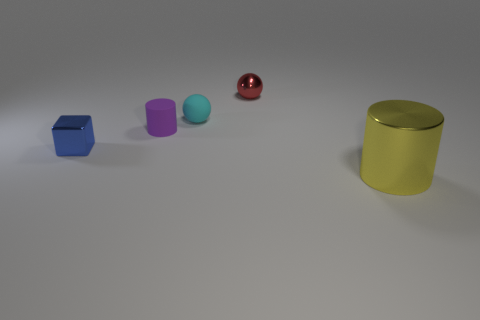Are the small cyan thing and the small block made of the same material?
Offer a terse response. No. Are there any matte cylinders in front of the cylinder that is on the left side of the large yellow metallic cylinder?
Offer a terse response. No. What number of small objects are left of the tiny cyan rubber sphere and behind the small cyan ball?
Provide a succinct answer. 0. There is a tiny metal object that is behind the tiny matte ball; what is its shape?
Offer a very short reply. Sphere. What number of yellow objects have the same size as the blue thing?
Your response must be concise. 0. Is the color of the tiny sphere that is on the left side of the red metallic sphere the same as the large metallic thing?
Provide a short and direct response. No. There is a thing that is both in front of the small cyan matte sphere and behind the small blue thing; what is its material?
Keep it short and to the point. Rubber. Are there more small red metal objects than large red spheres?
Offer a terse response. Yes. The cylinder that is behind the cylinder that is on the right side of the cylinder that is to the left of the large cylinder is what color?
Provide a succinct answer. Purple. Do the cylinder that is on the left side of the big yellow metallic cylinder and the block have the same material?
Provide a succinct answer. No. 